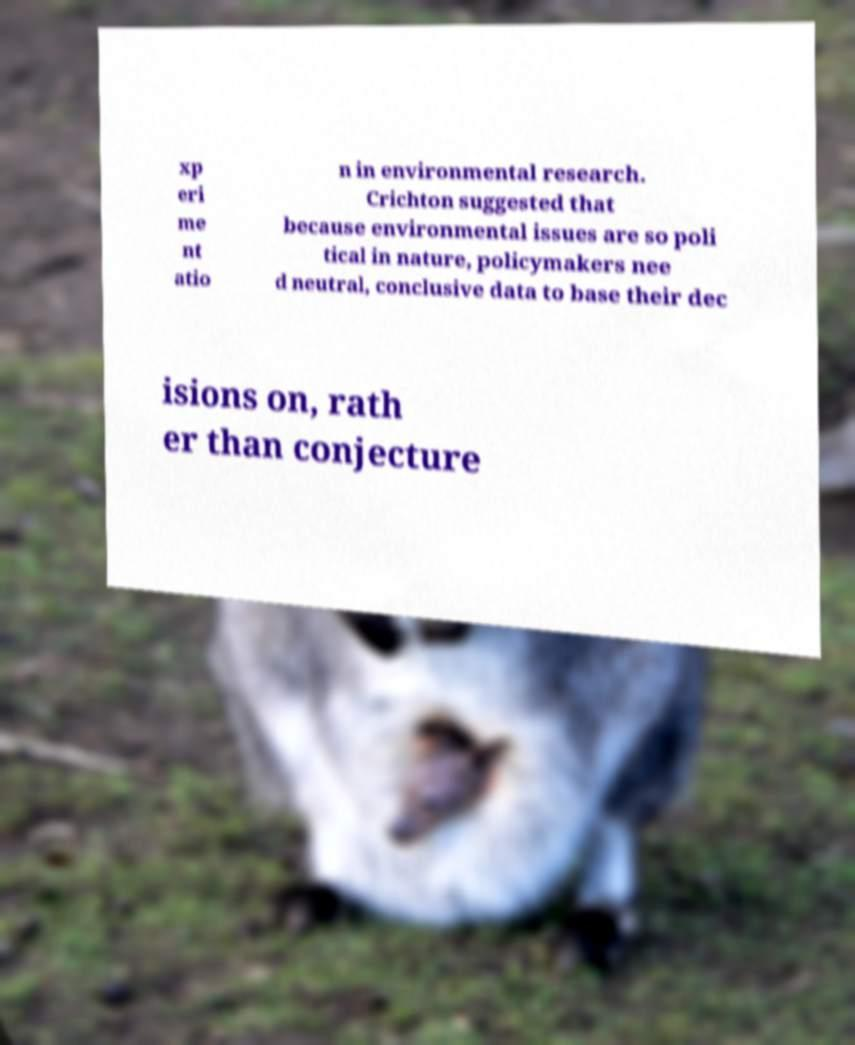What messages or text are displayed in this image? I need them in a readable, typed format. xp eri me nt atio n in environmental research. Crichton suggested that because environmental issues are so poli tical in nature, policymakers nee d neutral, conclusive data to base their dec isions on, rath er than conjecture 